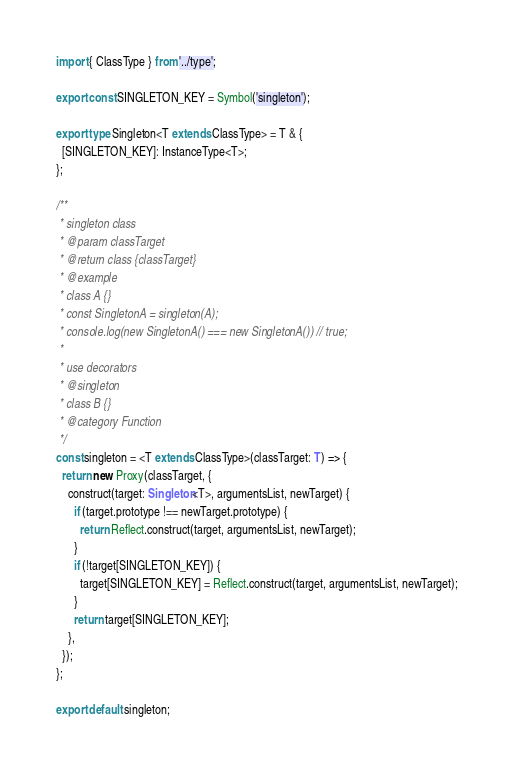<code> <loc_0><loc_0><loc_500><loc_500><_TypeScript_>import { ClassType } from '../type';

export const SINGLETON_KEY = Symbol('singleton');

export type Singleton<T extends ClassType> = T & {
  [SINGLETON_KEY]: InstanceType<T>;
};

/**
 * singleton class
 * @param classTarget
 * @return class {classTarget}
 * @example
 * class A {}
 * const SingletonA = singleton(A);
 * console.log(new SingletonA() === new SingletonA()) // true;
 *
 * use decorators
 * @singleton
 * class B {}
 * @category Function
 */
const singleton = <T extends ClassType>(classTarget: T) => {
  return new Proxy(classTarget, {
    construct(target: Singleton<T>, argumentsList, newTarget) {
      if (target.prototype !== newTarget.prototype) {
        return Reflect.construct(target, argumentsList, newTarget);
      }
      if (!target[SINGLETON_KEY]) {
        target[SINGLETON_KEY] = Reflect.construct(target, argumentsList, newTarget);
      }
      return target[SINGLETON_KEY];
    },
  });
};

export default singleton;
</code> 